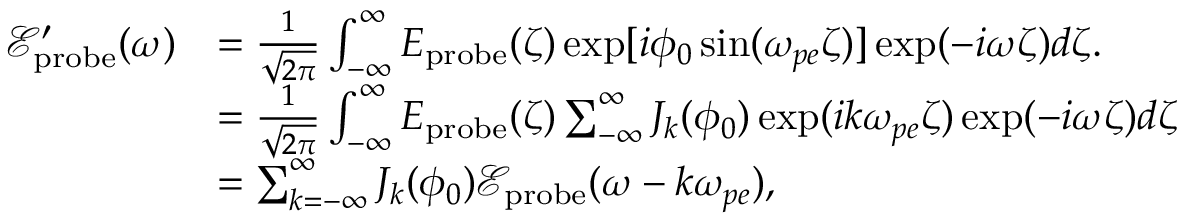<formula> <loc_0><loc_0><loc_500><loc_500>\begin{array} { r l } { \mathcal { E } _ { p r o b e } ^ { \prime } ( \omega ) } & { = \frac { 1 } { \sqrt { 2 \pi } } \int _ { - \infty } ^ { \infty } E _ { p r o b e } ( \zeta ) \exp [ i \phi _ { 0 } \sin ( \omega _ { p e } \zeta ) ] \exp ( - i \omega \zeta ) d \zeta . } \\ & { = \frac { 1 } { \sqrt { 2 \pi } } \int _ { - \infty } ^ { \infty } E _ { p r o b e } ( \zeta ) \sum _ { - \infty } ^ { \infty } J _ { k } ( \phi _ { 0 } ) \exp ( i k \omega _ { p e } \zeta ) \exp ( - i \omega \zeta ) d \zeta } \\ & { = \sum _ { k = - \infty } ^ { \infty } J _ { k } ( \phi _ { 0 } ) \mathcal { E } _ { p r o b e } ( \omega - k \omega _ { p e } ) , } \end{array}</formula> 